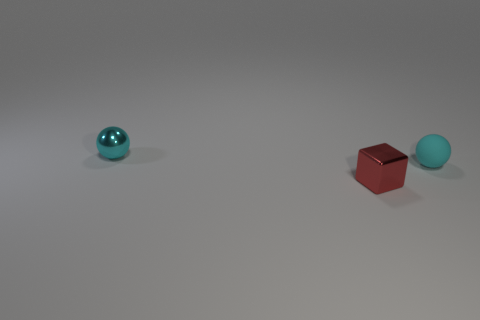Add 1 cyan spheres. How many objects exist? 4 Subtract all blocks. How many objects are left? 2 Add 1 blocks. How many blocks are left? 2 Add 1 brown blocks. How many brown blocks exist? 1 Subtract 0 yellow cylinders. How many objects are left? 3 Subtract all tiny rubber objects. Subtract all purple spheres. How many objects are left? 2 